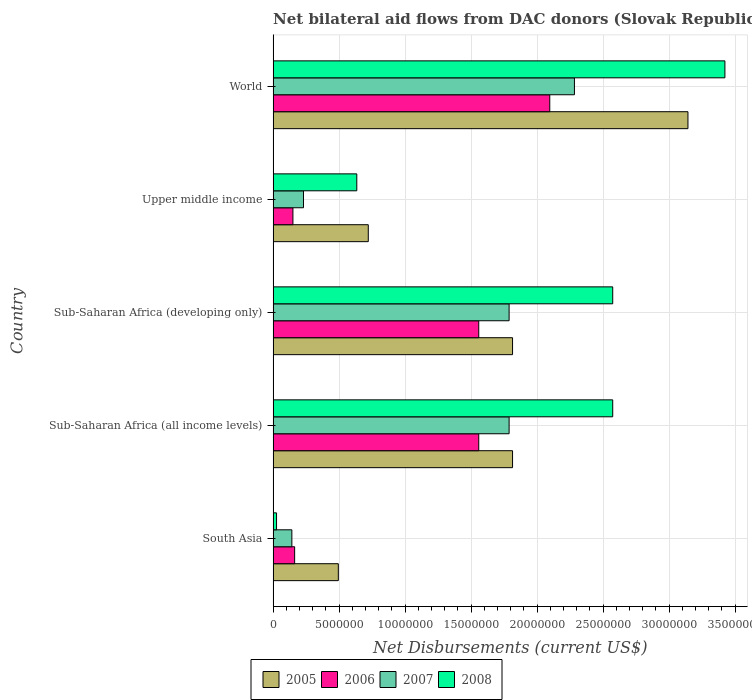How many groups of bars are there?
Provide a short and direct response. 5. Are the number of bars on each tick of the Y-axis equal?
Your response must be concise. Yes. How many bars are there on the 3rd tick from the bottom?
Make the answer very short. 4. What is the net bilateral aid flows in 2006 in South Asia?
Ensure brevity in your answer.  1.63e+06. Across all countries, what is the maximum net bilateral aid flows in 2006?
Keep it short and to the point. 2.10e+07. Across all countries, what is the minimum net bilateral aid flows in 2006?
Offer a terse response. 1.50e+06. In which country was the net bilateral aid flows in 2005 maximum?
Make the answer very short. World. In which country was the net bilateral aid flows in 2006 minimum?
Ensure brevity in your answer.  Upper middle income. What is the total net bilateral aid flows in 2007 in the graph?
Your answer should be very brief. 6.23e+07. What is the difference between the net bilateral aid flows in 2005 in South Asia and that in World?
Give a very brief answer. -2.65e+07. What is the difference between the net bilateral aid flows in 2005 in South Asia and the net bilateral aid flows in 2007 in Sub-Saharan Africa (developing only)?
Your response must be concise. -1.29e+07. What is the average net bilateral aid flows in 2008 per country?
Make the answer very short. 1.85e+07. What is the difference between the net bilateral aid flows in 2007 and net bilateral aid flows in 2008 in Sub-Saharan Africa (developing only)?
Give a very brief answer. -7.85e+06. What is the ratio of the net bilateral aid flows in 2005 in Sub-Saharan Africa (developing only) to that in World?
Provide a short and direct response. 0.58. Is the net bilateral aid flows in 2006 in Sub-Saharan Africa (all income levels) less than that in Upper middle income?
Give a very brief answer. No. Is the difference between the net bilateral aid flows in 2007 in Sub-Saharan Africa (all income levels) and Sub-Saharan Africa (developing only) greater than the difference between the net bilateral aid flows in 2008 in Sub-Saharan Africa (all income levels) and Sub-Saharan Africa (developing only)?
Offer a terse response. No. What is the difference between the highest and the second highest net bilateral aid flows in 2008?
Your answer should be compact. 8.50e+06. What is the difference between the highest and the lowest net bilateral aid flows in 2008?
Give a very brief answer. 3.40e+07. Is it the case that in every country, the sum of the net bilateral aid flows in 2008 and net bilateral aid flows in 2006 is greater than the sum of net bilateral aid flows in 2005 and net bilateral aid flows in 2007?
Your answer should be very brief. No. What does the 1st bar from the bottom in Upper middle income represents?
Offer a terse response. 2005. Is it the case that in every country, the sum of the net bilateral aid flows in 2007 and net bilateral aid flows in 2005 is greater than the net bilateral aid flows in 2008?
Provide a short and direct response. Yes. How many bars are there?
Offer a very short reply. 20. Are all the bars in the graph horizontal?
Your answer should be very brief. Yes. Are the values on the major ticks of X-axis written in scientific E-notation?
Ensure brevity in your answer.  No. Does the graph contain any zero values?
Provide a short and direct response. No. Where does the legend appear in the graph?
Offer a very short reply. Bottom center. How many legend labels are there?
Provide a succinct answer. 4. How are the legend labels stacked?
Your response must be concise. Horizontal. What is the title of the graph?
Offer a terse response. Net bilateral aid flows from DAC donors (Slovak Republic). Does "1961" appear as one of the legend labels in the graph?
Your answer should be compact. No. What is the label or title of the X-axis?
Give a very brief answer. Net Disbursements (current US$). What is the label or title of the Y-axis?
Ensure brevity in your answer.  Country. What is the Net Disbursements (current US$) of 2005 in South Asia?
Offer a terse response. 4.94e+06. What is the Net Disbursements (current US$) in 2006 in South Asia?
Your response must be concise. 1.63e+06. What is the Net Disbursements (current US$) of 2007 in South Asia?
Provide a short and direct response. 1.42e+06. What is the Net Disbursements (current US$) in 2005 in Sub-Saharan Africa (all income levels)?
Your answer should be compact. 1.81e+07. What is the Net Disbursements (current US$) of 2006 in Sub-Saharan Africa (all income levels)?
Your answer should be very brief. 1.56e+07. What is the Net Disbursements (current US$) in 2007 in Sub-Saharan Africa (all income levels)?
Your answer should be very brief. 1.79e+07. What is the Net Disbursements (current US$) in 2008 in Sub-Saharan Africa (all income levels)?
Keep it short and to the point. 2.57e+07. What is the Net Disbursements (current US$) in 2005 in Sub-Saharan Africa (developing only)?
Keep it short and to the point. 1.81e+07. What is the Net Disbursements (current US$) in 2006 in Sub-Saharan Africa (developing only)?
Offer a terse response. 1.56e+07. What is the Net Disbursements (current US$) in 2007 in Sub-Saharan Africa (developing only)?
Keep it short and to the point. 1.79e+07. What is the Net Disbursements (current US$) in 2008 in Sub-Saharan Africa (developing only)?
Keep it short and to the point. 2.57e+07. What is the Net Disbursements (current US$) in 2005 in Upper middle income?
Your answer should be compact. 7.21e+06. What is the Net Disbursements (current US$) of 2006 in Upper middle income?
Make the answer very short. 1.50e+06. What is the Net Disbursements (current US$) of 2007 in Upper middle income?
Provide a short and direct response. 2.30e+06. What is the Net Disbursements (current US$) of 2008 in Upper middle income?
Your answer should be very brief. 6.34e+06. What is the Net Disbursements (current US$) in 2005 in World?
Keep it short and to the point. 3.14e+07. What is the Net Disbursements (current US$) of 2006 in World?
Provide a short and direct response. 2.10e+07. What is the Net Disbursements (current US$) of 2007 in World?
Offer a very short reply. 2.28e+07. What is the Net Disbursements (current US$) in 2008 in World?
Your response must be concise. 3.42e+07. Across all countries, what is the maximum Net Disbursements (current US$) in 2005?
Offer a terse response. 3.14e+07. Across all countries, what is the maximum Net Disbursements (current US$) of 2006?
Provide a short and direct response. 2.10e+07. Across all countries, what is the maximum Net Disbursements (current US$) of 2007?
Make the answer very short. 2.28e+07. Across all countries, what is the maximum Net Disbursements (current US$) of 2008?
Keep it short and to the point. 3.42e+07. Across all countries, what is the minimum Net Disbursements (current US$) of 2005?
Your response must be concise. 4.94e+06. Across all countries, what is the minimum Net Disbursements (current US$) of 2006?
Provide a succinct answer. 1.50e+06. Across all countries, what is the minimum Net Disbursements (current US$) of 2007?
Your response must be concise. 1.42e+06. Across all countries, what is the minimum Net Disbursements (current US$) in 2008?
Your answer should be compact. 2.60e+05. What is the total Net Disbursements (current US$) in 2005 in the graph?
Provide a short and direct response. 7.99e+07. What is the total Net Disbursements (current US$) in 2006 in the graph?
Keep it short and to the point. 5.52e+07. What is the total Net Disbursements (current US$) in 2007 in the graph?
Ensure brevity in your answer.  6.23e+07. What is the total Net Disbursements (current US$) of 2008 in the graph?
Your answer should be compact. 9.23e+07. What is the difference between the Net Disbursements (current US$) of 2005 in South Asia and that in Sub-Saharan Africa (all income levels)?
Your answer should be very brief. -1.32e+07. What is the difference between the Net Disbursements (current US$) of 2006 in South Asia and that in Sub-Saharan Africa (all income levels)?
Ensure brevity in your answer.  -1.40e+07. What is the difference between the Net Disbursements (current US$) in 2007 in South Asia and that in Sub-Saharan Africa (all income levels)?
Offer a terse response. -1.65e+07. What is the difference between the Net Disbursements (current US$) of 2008 in South Asia and that in Sub-Saharan Africa (all income levels)?
Your response must be concise. -2.55e+07. What is the difference between the Net Disbursements (current US$) of 2005 in South Asia and that in Sub-Saharan Africa (developing only)?
Your answer should be very brief. -1.32e+07. What is the difference between the Net Disbursements (current US$) in 2006 in South Asia and that in Sub-Saharan Africa (developing only)?
Make the answer very short. -1.40e+07. What is the difference between the Net Disbursements (current US$) in 2007 in South Asia and that in Sub-Saharan Africa (developing only)?
Give a very brief answer. -1.65e+07. What is the difference between the Net Disbursements (current US$) of 2008 in South Asia and that in Sub-Saharan Africa (developing only)?
Your answer should be compact. -2.55e+07. What is the difference between the Net Disbursements (current US$) of 2005 in South Asia and that in Upper middle income?
Your answer should be compact. -2.27e+06. What is the difference between the Net Disbursements (current US$) of 2006 in South Asia and that in Upper middle income?
Offer a terse response. 1.30e+05. What is the difference between the Net Disbursements (current US$) of 2007 in South Asia and that in Upper middle income?
Your answer should be compact. -8.80e+05. What is the difference between the Net Disbursements (current US$) in 2008 in South Asia and that in Upper middle income?
Offer a very short reply. -6.08e+06. What is the difference between the Net Disbursements (current US$) of 2005 in South Asia and that in World?
Give a very brief answer. -2.65e+07. What is the difference between the Net Disbursements (current US$) of 2006 in South Asia and that in World?
Provide a short and direct response. -1.93e+07. What is the difference between the Net Disbursements (current US$) of 2007 in South Asia and that in World?
Give a very brief answer. -2.14e+07. What is the difference between the Net Disbursements (current US$) of 2008 in South Asia and that in World?
Your answer should be compact. -3.40e+07. What is the difference between the Net Disbursements (current US$) of 2006 in Sub-Saharan Africa (all income levels) and that in Sub-Saharan Africa (developing only)?
Make the answer very short. 0. What is the difference between the Net Disbursements (current US$) of 2005 in Sub-Saharan Africa (all income levels) and that in Upper middle income?
Offer a very short reply. 1.09e+07. What is the difference between the Net Disbursements (current US$) of 2006 in Sub-Saharan Africa (all income levels) and that in Upper middle income?
Your answer should be compact. 1.41e+07. What is the difference between the Net Disbursements (current US$) in 2007 in Sub-Saharan Africa (all income levels) and that in Upper middle income?
Offer a very short reply. 1.56e+07. What is the difference between the Net Disbursements (current US$) in 2008 in Sub-Saharan Africa (all income levels) and that in Upper middle income?
Ensure brevity in your answer.  1.94e+07. What is the difference between the Net Disbursements (current US$) of 2005 in Sub-Saharan Africa (all income levels) and that in World?
Your answer should be very brief. -1.33e+07. What is the difference between the Net Disbursements (current US$) in 2006 in Sub-Saharan Africa (all income levels) and that in World?
Provide a succinct answer. -5.38e+06. What is the difference between the Net Disbursements (current US$) of 2007 in Sub-Saharan Africa (all income levels) and that in World?
Your answer should be very brief. -4.95e+06. What is the difference between the Net Disbursements (current US$) in 2008 in Sub-Saharan Africa (all income levels) and that in World?
Ensure brevity in your answer.  -8.50e+06. What is the difference between the Net Disbursements (current US$) of 2005 in Sub-Saharan Africa (developing only) and that in Upper middle income?
Keep it short and to the point. 1.09e+07. What is the difference between the Net Disbursements (current US$) in 2006 in Sub-Saharan Africa (developing only) and that in Upper middle income?
Your answer should be compact. 1.41e+07. What is the difference between the Net Disbursements (current US$) in 2007 in Sub-Saharan Africa (developing only) and that in Upper middle income?
Offer a very short reply. 1.56e+07. What is the difference between the Net Disbursements (current US$) of 2008 in Sub-Saharan Africa (developing only) and that in Upper middle income?
Make the answer very short. 1.94e+07. What is the difference between the Net Disbursements (current US$) of 2005 in Sub-Saharan Africa (developing only) and that in World?
Give a very brief answer. -1.33e+07. What is the difference between the Net Disbursements (current US$) of 2006 in Sub-Saharan Africa (developing only) and that in World?
Provide a succinct answer. -5.38e+06. What is the difference between the Net Disbursements (current US$) of 2007 in Sub-Saharan Africa (developing only) and that in World?
Offer a very short reply. -4.95e+06. What is the difference between the Net Disbursements (current US$) of 2008 in Sub-Saharan Africa (developing only) and that in World?
Provide a short and direct response. -8.50e+06. What is the difference between the Net Disbursements (current US$) of 2005 in Upper middle income and that in World?
Offer a very short reply. -2.42e+07. What is the difference between the Net Disbursements (current US$) in 2006 in Upper middle income and that in World?
Ensure brevity in your answer.  -1.95e+07. What is the difference between the Net Disbursements (current US$) in 2007 in Upper middle income and that in World?
Offer a very short reply. -2.05e+07. What is the difference between the Net Disbursements (current US$) in 2008 in Upper middle income and that in World?
Make the answer very short. -2.79e+07. What is the difference between the Net Disbursements (current US$) in 2005 in South Asia and the Net Disbursements (current US$) in 2006 in Sub-Saharan Africa (all income levels)?
Provide a short and direct response. -1.06e+07. What is the difference between the Net Disbursements (current US$) of 2005 in South Asia and the Net Disbursements (current US$) of 2007 in Sub-Saharan Africa (all income levels)?
Provide a short and direct response. -1.29e+07. What is the difference between the Net Disbursements (current US$) in 2005 in South Asia and the Net Disbursements (current US$) in 2008 in Sub-Saharan Africa (all income levels)?
Your answer should be very brief. -2.08e+07. What is the difference between the Net Disbursements (current US$) in 2006 in South Asia and the Net Disbursements (current US$) in 2007 in Sub-Saharan Africa (all income levels)?
Your answer should be very brief. -1.62e+07. What is the difference between the Net Disbursements (current US$) in 2006 in South Asia and the Net Disbursements (current US$) in 2008 in Sub-Saharan Africa (all income levels)?
Your response must be concise. -2.41e+07. What is the difference between the Net Disbursements (current US$) of 2007 in South Asia and the Net Disbursements (current US$) of 2008 in Sub-Saharan Africa (all income levels)?
Make the answer very short. -2.43e+07. What is the difference between the Net Disbursements (current US$) in 2005 in South Asia and the Net Disbursements (current US$) in 2006 in Sub-Saharan Africa (developing only)?
Offer a very short reply. -1.06e+07. What is the difference between the Net Disbursements (current US$) in 2005 in South Asia and the Net Disbursements (current US$) in 2007 in Sub-Saharan Africa (developing only)?
Offer a terse response. -1.29e+07. What is the difference between the Net Disbursements (current US$) in 2005 in South Asia and the Net Disbursements (current US$) in 2008 in Sub-Saharan Africa (developing only)?
Your answer should be very brief. -2.08e+07. What is the difference between the Net Disbursements (current US$) of 2006 in South Asia and the Net Disbursements (current US$) of 2007 in Sub-Saharan Africa (developing only)?
Your response must be concise. -1.62e+07. What is the difference between the Net Disbursements (current US$) in 2006 in South Asia and the Net Disbursements (current US$) in 2008 in Sub-Saharan Africa (developing only)?
Your answer should be very brief. -2.41e+07. What is the difference between the Net Disbursements (current US$) of 2007 in South Asia and the Net Disbursements (current US$) of 2008 in Sub-Saharan Africa (developing only)?
Keep it short and to the point. -2.43e+07. What is the difference between the Net Disbursements (current US$) in 2005 in South Asia and the Net Disbursements (current US$) in 2006 in Upper middle income?
Your answer should be compact. 3.44e+06. What is the difference between the Net Disbursements (current US$) in 2005 in South Asia and the Net Disbursements (current US$) in 2007 in Upper middle income?
Provide a succinct answer. 2.64e+06. What is the difference between the Net Disbursements (current US$) of 2005 in South Asia and the Net Disbursements (current US$) of 2008 in Upper middle income?
Provide a short and direct response. -1.40e+06. What is the difference between the Net Disbursements (current US$) of 2006 in South Asia and the Net Disbursements (current US$) of 2007 in Upper middle income?
Provide a short and direct response. -6.70e+05. What is the difference between the Net Disbursements (current US$) of 2006 in South Asia and the Net Disbursements (current US$) of 2008 in Upper middle income?
Give a very brief answer. -4.71e+06. What is the difference between the Net Disbursements (current US$) in 2007 in South Asia and the Net Disbursements (current US$) in 2008 in Upper middle income?
Offer a very short reply. -4.92e+06. What is the difference between the Net Disbursements (current US$) of 2005 in South Asia and the Net Disbursements (current US$) of 2006 in World?
Ensure brevity in your answer.  -1.60e+07. What is the difference between the Net Disbursements (current US$) in 2005 in South Asia and the Net Disbursements (current US$) in 2007 in World?
Your answer should be very brief. -1.79e+07. What is the difference between the Net Disbursements (current US$) in 2005 in South Asia and the Net Disbursements (current US$) in 2008 in World?
Provide a succinct answer. -2.93e+07. What is the difference between the Net Disbursements (current US$) in 2006 in South Asia and the Net Disbursements (current US$) in 2007 in World?
Offer a terse response. -2.12e+07. What is the difference between the Net Disbursements (current US$) of 2006 in South Asia and the Net Disbursements (current US$) of 2008 in World?
Offer a very short reply. -3.26e+07. What is the difference between the Net Disbursements (current US$) in 2007 in South Asia and the Net Disbursements (current US$) in 2008 in World?
Make the answer very short. -3.28e+07. What is the difference between the Net Disbursements (current US$) in 2005 in Sub-Saharan Africa (all income levels) and the Net Disbursements (current US$) in 2006 in Sub-Saharan Africa (developing only)?
Offer a very short reply. 2.56e+06. What is the difference between the Net Disbursements (current US$) in 2005 in Sub-Saharan Africa (all income levels) and the Net Disbursements (current US$) in 2007 in Sub-Saharan Africa (developing only)?
Make the answer very short. 2.60e+05. What is the difference between the Net Disbursements (current US$) of 2005 in Sub-Saharan Africa (all income levels) and the Net Disbursements (current US$) of 2008 in Sub-Saharan Africa (developing only)?
Keep it short and to the point. -7.59e+06. What is the difference between the Net Disbursements (current US$) of 2006 in Sub-Saharan Africa (all income levels) and the Net Disbursements (current US$) of 2007 in Sub-Saharan Africa (developing only)?
Provide a short and direct response. -2.30e+06. What is the difference between the Net Disbursements (current US$) of 2006 in Sub-Saharan Africa (all income levels) and the Net Disbursements (current US$) of 2008 in Sub-Saharan Africa (developing only)?
Your response must be concise. -1.02e+07. What is the difference between the Net Disbursements (current US$) in 2007 in Sub-Saharan Africa (all income levels) and the Net Disbursements (current US$) in 2008 in Sub-Saharan Africa (developing only)?
Make the answer very short. -7.85e+06. What is the difference between the Net Disbursements (current US$) in 2005 in Sub-Saharan Africa (all income levels) and the Net Disbursements (current US$) in 2006 in Upper middle income?
Your response must be concise. 1.66e+07. What is the difference between the Net Disbursements (current US$) of 2005 in Sub-Saharan Africa (all income levels) and the Net Disbursements (current US$) of 2007 in Upper middle income?
Provide a short and direct response. 1.58e+07. What is the difference between the Net Disbursements (current US$) of 2005 in Sub-Saharan Africa (all income levels) and the Net Disbursements (current US$) of 2008 in Upper middle income?
Your answer should be compact. 1.18e+07. What is the difference between the Net Disbursements (current US$) of 2006 in Sub-Saharan Africa (all income levels) and the Net Disbursements (current US$) of 2007 in Upper middle income?
Offer a terse response. 1.33e+07. What is the difference between the Net Disbursements (current US$) in 2006 in Sub-Saharan Africa (all income levels) and the Net Disbursements (current US$) in 2008 in Upper middle income?
Provide a short and direct response. 9.24e+06. What is the difference between the Net Disbursements (current US$) in 2007 in Sub-Saharan Africa (all income levels) and the Net Disbursements (current US$) in 2008 in Upper middle income?
Your answer should be compact. 1.15e+07. What is the difference between the Net Disbursements (current US$) in 2005 in Sub-Saharan Africa (all income levels) and the Net Disbursements (current US$) in 2006 in World?
Keep it short and to the point. -2.82e+06. What is the difference between the Net Disbursements (current US$) in 2005 in Sub-Saharan Africa (all income levels) and the Net Disbursements (current US$) in 2007 in World?
Your response must be concise. -4.69e+06. What is the difference between the Net Disbursements (current US$) of 2005 in Sub-Saharan Africa (all income levels) and the Net Disbursements (current US$) of 2008 in World?
Your answer should be very brief. -1.61e+07. What is the difference between the Net Disbursements (current US$) of 2006 in Sub-Saharan Africa (all income levels) and the Net Disbursements (current US$) of 2007 in World?
Keep it short and to the point. -7.25e+06. What is the difference between the Net Disbursements (current US$) in 2006 in Sub-Saharan Africa (all income levels) and the Net Disbursements (current US$) in 2008 in World?
Provide a short and direct response. -1.86e+07. What is the difference between the Net Disbursements (current US$) in 2007 in Sub-Saharan Africa (all income levels) and the Net Disbursements (current US$) in 2008 in World?
Make the answer very short. -1.64e+07. What is the difference between the Net Disbursements (current US$) in 2005 in Sub-Saharan Africa (developing only) and the Net Disbursements (current US$) in 2006 in Upper middle income?
Offer a terse response. 1.66e+07. What is the difference between the Net Disbursements (current US$) in 2005 in Sub-Saharan Africa (developing only) and the Net Disbursements (current US$) in 2007 in Upper middle income?
Provide a succinct answer. 1.58e+07. What is the difference between the Net Disbursements (current US$) of 2005 in Sub-Saharan Africa (developing only) and the Net Disbursements (current US$) of 2008 in Upper middle income?
Provide a succinct answer. 1.18e+07. What is the difference between the Net Disbursements (current US$) of 2006 in Sub-Saharan Africa (developing only) and the Net Disbursements (current US$) of 2007 in Upper middle income?
Ensure brevity in your answer.  1.33e+07. What is the difference between the Net Disbursements (current US$) in 2006 in Sub-Saharan Africa (developing only) and the Net Disbursements (current US$) in 2008 in Upper middle income?
Keep it short and to the point. 9.24e+06. What is the difference between the Net Disbursements (current US$) of 2007 in Sub-Saharan Africa (developing only) and the Net Disbursements (current US$) of 2008 in Upper middle income?
Keep it short and to the point. 1.15e+07. What is the difference between the Net Disbursements (current US$) of 2005 in Sub-Saharan Africa (developing only) and the Net Disbursements (current US$) of 2006 in World?
Provide a succinct answer. -2.82e+06. What is the difference between the Net Disbursements (current US$) in 2005 in Sub-Saharan Africa (developing only) and the Net Disbursements (current US$) in 2007 in World?
Your answer should be very brief. -4.69e+06. What is the difference between the Net Disbursements (current US$) in 2005 in Sub-Saharan Africa (developing only) and the Net Disbursements (current US$) in 2008 in World?
Ensure brevity in your answer.  -1.61e+07. What is the difference between the Net Disbursements (current US$) of 2006 in Sub-Saharan Africa (developing only) and the Net Disbursements (current US$) of 2007 in World?
Make the answer very short. -7.25e+06. What is the difference between the Net Disbursements (current US$) of 2006 in Sub-Saharan Africa (developing only) and the Net Disbursements (current US$) of 2008 in World?
Offer a terse response. -1.86e+07. What is the difference between the Net Disbursements (current US$) in 2007 in Sub-Saharan Africa (developing only) and the Net Disbursements (current US$) in 2008 in World?
Your answer should be very brief. -1.64e+07. What is the difference between the Net Disbursements (current US$) of 2005 in Upper middle income and the Net Disbursements (current US$) of 2006 in World?
Keep it short and to the point. -1.38e+07. What is the difference between the Net Disbursements (current US$) of 2005 in Upper middle income and the Net Disbursements (current US$) of 2007 in World?
Your answer should be compact. -1.56e+07. What is the difference between the Net Disbursements (current US$) of 2005 in Upper middle income and the Net Disbursements (current US$) of 2008 in World?
Your response must be concise. -2.70e+07. What is the difference between the Net Disbursements (current US$) of 2006 in Upper middle income and the Net Disbursements (current US$) of 2007 in World?
Make the answer very short. -2.13e+07. What is the difference between the Net Disbursements (current US$) of 2006 in Upper middle income and the Net Disbursements (current US$) of 2008 in World?
Your answer should be very brief. -3.27e+07. What is the difference between the Net Disbursements (current US$) of 2007 in Upper middle income and the Net Disbursements (current US$) of 2008 in World?
Provide a short and direct response. -3.19e+07. What is the average Net Disbursements (current US$) in 2005 per country?
Make the answer very short. 1.60e+07. What is the average Net Disbursements (current US$) in 2006 per country?
Provide a succinct answer. 1.10e+07. What is the average Net Disbursements (current US$) in 2007 per country?
Give a very brief answer. 1.25e+07. What is the average Net Disbursements (current US$) of 2008 per country?
Make the answer very short. 1.85e+07. What is the difference between the Net Disbursements (current US$) in 2005 and Net Disbursements (current US$) in 2006 in South Asia?
Provide a short and direct response. 3.31e+06. What is the difference between the Net Disbursements (current US$) in 2005 and Net Disbursements (current US$) in 2007 in South Asia?
Your response must be concise. 3.52e+06. What is the difference between the Net Disbursements (current US$) of 2005 and Net Disbursements (current US$) of 2008 in South Asia?
Provide a succinct answer. 4.68e+06. What is the difference between the Net Disbursements (current US$) of 2006 and Net Disbursements (current US$) of 2008 in South Asia?
Offer a terse response. 1.37e+06. What is the difference between the Net Disbursements (current US$) in 2007 and Net Disbursements (current US$) in 2008 in South Asia?
Make the answer very short. 1.16e+06. What is the difference between the Net Disbursements (current US$) of 2005 and Net Disbursements (current US$) of 2006 in Sub-Saharan Africa (all income levels)?
Your answer should be very brief. 2.56e+06. What is the difference between the Net Disbursements (current US$) in 2005 and Net Disbursements (current US$) in 2007 in Sub-Saharan Africa (all income levels)?
Keep it short and to the point. 2.60e+05. What is the difference between the Net Disbursements (current US$) of 2005 and Net Disbursements (current US$) of 2008 in Sub-Saharan Africa (all income levels)?
Keep it short and to the point. -7.59e+06. What is the difference between the Net Disbursements (current US$) of 2006 and Net Disbursements (current US$) of 2007 in Sub-Saharan Africa (all income levels)?
Provide a short and direct response. -2.30e+06. What is the difference between the Net Disbursements (current US$) of 2006 and Net Disbursements (current US$) of 2008 in Sub-Saharan Africa (all income levels)?
Ensure brevity in your answer.  -1.02e+07. What is the difference between the Net Disbursements (current US$) of 2007 and Net Disbursements (current US$) of 2008 in Sub-Saharan Africa (all income levels)?
Offer a terse response. -7.85e+06. What is the difference between the Net Disbursements (current US$) in 2005 and Net Disbursements (current US$) in 2006 in Sub-Saharan Africa (developing only)?
Keep it short and to the point. 2.56e+06. What is the difference between the Net Disbursements (current US$) of 2005 and Net Disbursements (current US$) of 2008 in Sub-Saharan Africa (developing only)?
Keep it short and to the point. -7.59e+06. What is the difference between the Net Disbursements (current US$) in 2006 and Net Disbursements (current US$) in 2007 in Sub-Saharan Africa (developing only)?
Your response must be concise. -2.30e+06. What is the difference between the Net Disbursements (current US$) in 2006 and Net Disbursements (current US$) in 2008 in Sub-Saharan Africa (developing only)?
Offer a very short reply. -1.02e+07. What is the difference between the Net Disbursements (current US$) of 2007 and Net Disbursements (current US$) of 2008 in Sub-Saharan Africa (developing only)?
Your response must be concise. -7.85e+06. What is the difference between the Net Disbursements (current US$) in 2005 and Net Disbursements (current US$) in 2006 in Upper middle income?
Provide a short and direct response. 5.71e+06. What is the difference between the Net Disbursements (current US$) in 2005 and Net Disbursements (current US$) in 2007 in Upper middle income?
Ensure brevity in your answer.  4.91e+06. What is the difference between the Net Disbursements (current US$) of 2005 and Net Disbursements (current US$) of 2008 in Upper middle income?
Offer a terse response. 8.70e+05. What is the difference between the Net Disbursements (current US$) of 2006 and Net Disbursements (current US$) of 2007 in Upper middle income?
Keep it short and to the point. -8.00e+05. What is the difference between the Net Disbursements (current US$) of 2006 and Net Disbursements (current US$) of 2008 in Upper middle income?
Make the answer very short. -4.84e+06. What is the difference between the Net Disbursements (current US$) in 2007 and Net Disbursements (current US$) in 2008 in Upper middle income?
Provide a succinct answer. -4.04e+06. What is the difference between the Net Disbursements (current US$) of 2005 and Net Disbursements (current US$) of 2006 in World?
Provide a short and direct response. 1.05e+07. What is the difference between the Net Disbursements (current US$) of 2005 and Net Disbursements (current US$) of 2007 in World?
Offer a terse response. 8.60e+06. What is the difference between the Net Disbursements (current US$) in 2005 and Net Disbursements (current US$) in 2008 in World?
Keep it short and to the point. -2.80e+06. What is the difference between the Net Disbursements (current US$) of 2006 and Net Disbursements (current US$) of 2007 in World?
Keep it short and to the point. -1.87e+06. What is the difference between the Net Disbursements (current US$) of 2006 and Net Disbursements (current US$) of 2008 in World?
Offer a terse response. -1.33e+07. What is the difference between the Net Disbursements (current US$) in 2007 and Net Disbursements (current US$) in 2008 in World?
Ensure brevity in your answer.  -1.14e+07. What is the ratio of the Net Disbursements (current US$) of 2005 in South Asia to that in Sub-Saharan Africa (all income levels)?
Keep it short and to the point. 0.27. What is the ratio of the Net Disbursements (current US$) of 2006 in South Asia to that in Sub-Saharan Africa (all income levels)?
Ensure brevity in your answer.  0.1. What is the ratio of the Net Disbursements (current US$) of 2007 in South Asia to that in Sub-Saharan Africa (all income levels)?
Provide a succinct answer. 0.08. What is the ratio of the Net Disbursements (current US$) of 2008 in South Asia to that in Sub-Saharan Africa (all income levels)?
Your answer should be very brief. 0.01. What is the ratio of the Net Disbursements (current US$) in 2005 in South Asia to that in Sub-Saharan Africa (developing only)?
Offer a terse response. 0.27. What is the ratio of the Net Disbursements (current US$) of 2006 in South Asia to that in Sub-Saharan Africa (developing only)?
Make the answer very short. 0.1. What is the ratio of the Net Disbursements (current US$) in 2007 in South Asia to that in Sub-Saharan Africa (developing only)?
Offer a terse response. 0.08. What is the ratio of the Net Disbursements (current US$) in 2008 in South Asia to that in Sub-Saharan Africa (developing only)?
Offer a very short reply. 0.01. What is the ratio of the Net Disbursements (current US$) of 2005 in South Asia to that in Upper middle income?
Offer a terse response. 0.69. What is the ratio of the Net Disbursements (current US$) in 2006 in South Asia to that in Upper middle income?
Provide a succinct answer. 1.09. What is the ratio of the Net Disbursements (current US$) of 2007 in South Asia to that in Upper middle income?
Provide a short and direct response. 0.62. What is the ratio of the Net Disbursements (current US$) in 2008 in South Asia to that in Upper middle income?
Keep it short and to the point. 0.04. What is the ratio of the Net Disbursements (current US$) in 2005 in South Asia to that in World?
Give a very brief answer. 0.16. What is the ratio of the Net Disbursements (current US$) in 2006 in South Asia to that in World?
Offer a terse response. 0.08. What is the ratio of the Net Disbursements (current US$) in 2007 in South Asia to that in World?
Provide a succinct answer. 0.06. What is the ratio of the Net Disbursements (current US$) in 2008 in South Asia to that in World?
Keep it short and to the point. 0.01. What is the ratio of the Net Disbursements (current US$) of 2005 in Sub-Saharan Africa (all income levels) to that in Upper middle income?
Ensure brevity in your answer.  2.52. What is the ratio of the Net Disbursements (current US$) in 2006 in Sub-Saharan Africa (all income levels) to that in Upper middle income?
Keep it short and to the point. 10.39. What is the ratio of the Net Disbursements (current US$) in 2007 in Sub-Saharan Africa (all income levels) to that in Upper middle income?
Your response must be concise. 7.77. What is the ratio of the Net Disbursements (current US$) of 2008 in Sub-Saharan Africa (all income levels) to that in Upper middle income?
Give a very brief answer. 4.06. What is the ratio of the Net Disbursements (current US$) of 2005 in Sub-Saharan Africa (all income levels) to that in World?
Give a very brief answer. 0.58. What is the ratio of the Net Disbursements (current US$) in 2006 in Sub-Saharan Africa (all income levels) to that in World?
Your answer should be very brief. 0.74. What is the ratio of the Net Disbursements (current US$) of 2007 in Sub-Saharan Africa (all income levels) to that in World?
Offer a very short reply. 0.78. What is the ratio of the Net Disbursements (current US$) of 2008 in Sub-Saharan Africa (all income levels) to that in World?
Keep it short and to the point. 0.75. What is the ratio of the Net Disbursements (current US$) in 2005 in Sub-Saharan Africa (developing only) to that in Upper middle income?
Give a very brief answer. 2.52. What is the ratio of the Net Disbursements (current US$) of 2006 in Sub-Saharan Africa (developing only) to that in Upper middle income?
Provide a succinct answer. 10.39. What is the ratio of the Net Disbursements (current US$) in 2007 in Sub-Saharan Africa (developing only) to that in Upper middle income?
Provide a succinct answer. 7.77. What is the ratio of the Net Disbursements (current US$) in 2008 in Sub-Saharan Africa (developing only) to that in Upper middle income?
Make the answer very short. 4.06. What is the ratio of the Net Disbursements (current US$) of 2005 in Sub-Saharan Africa (developing only) to that in World?
Provide a succinct answer. 0.58. What is the ratio of the Net Disbursements (current US$) of 2006 in Sub-Saharan Africa (developing only) to that in World?
Your answer should be compact. 0.74. What is the ratio of the Net Disbursements (current US$) of 2007 in Sub-Saharan Africa (developing only) to that in World?
Your response must be concise. 0.78. What is the ratio of the Net Disbursements (current US$) of 2008 in Sub-Saharan Africa (developing only) to that in World?
Make the answer very short. 0.75. What is the ratio of the Net Disbursements (current US$) of 2005 in Upper middle income to that in World?
Your answer should be compact. 0.23. What is the ratio of the Net Disbursements (current US$) of 2006 in Upper middle income to that in World?
Your answer should be very brief. 0.07. What is the ratio of the Net Disbursements (current US$) of 2007 in Upper middle income to that in World?
Your answer should be compact. 0.1. What is the ratio of the Net Disbursements (current US$) of 2008 in Upper middle income to that in World?
Your answer should be very brief. 0.19. What is the difference between the highest and the second highest Net Disbursements (current US$) in 2005?
Make the answer very short. 1.33e+07. What is the difference between the highest and the second highest Net Disbursements (current US$) in 2006?
Make the answer very short. 5.38e+06. What is the difference between the highest and the second highest Net Disbursements (current US$) in 2007?
Provide a succinct answer. 4.95e+06. What is the difference between the highest and the second highest Net Disbursements (current US$) in 2008?
Offer a terse response. 8.50e+06. What is the difference between the highest and the lowest Net Disbursements (current US$) in 2005?
Offer a terse response. 2.65e+07. What is the difference between the highest and the lowest Net Disbursements (current US$) in 2006?
Make the answer very short. 1.95e+07. What is the difference between the highest and the lowest Net Disbursements (current US$) of 2007?
Offer a very short reply. 2.14e+07. What is the difference between the highest and the lowest Net Disbursements (current US$) of 2008?
Your answer should be very brief. 3.40e+07. 